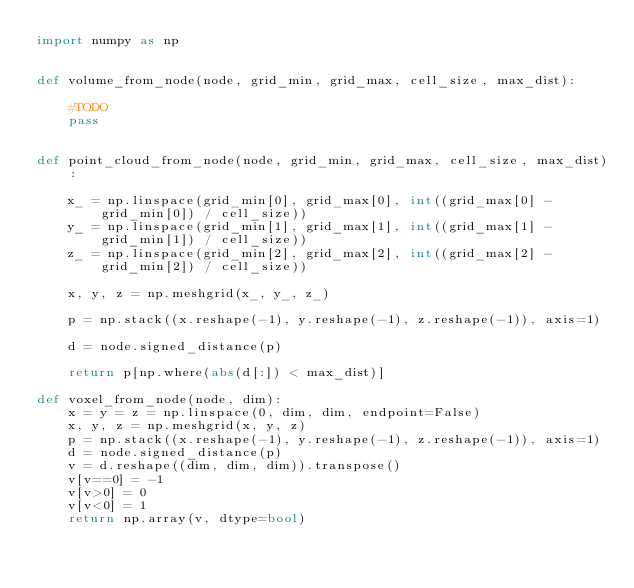<code> <loc_0><loc_0><loc_500><loc_500><_Python_>import numpy as np


def volume_from_node(node, grid_min, grid_max, cell_size, max_dist):

    #TODO
    pass


def point_cloud_from_node(node, grid_min, grid_max, cell_size, max_dist):

    x_ = np.linspace(grid_min[0], grid_max[0], int((grid_max[0] - grid_min[0]) / cell_size))
    y_ = np.linspace(grid_min[1], grid_max[1], int((grid_max[1] - grid_min[1]) / cell_size))
    z_ = np.linspace(grid_min[2], grid_max[2], int((grid_max[2] - grid_min[2]) / cell_size))

    x, y, z = np.meshgrid(x_, y_, z_)

    p = np.stack((x.reshape(-1), y.reshape(-1), z.reshape(-1)), axis=1)

    d = node.signed_distance(p)

    return p[np.where(abs(d[:]) < max_dist)]

def voxel_from_node(node, dim):
    x = y = z = np.linspace(0, dim, dim, endpoint=False)
    x, y, z = np.meshgrid(x, y, z)
    p = np.stack((x.reshape(-1), y.reshape(-1), z.reshape(-1)), axis=1)
    d = node.signed_distance(p)
    v = d.reshape((dim, dim, dim)).transpose()
    v[v==0] = -1
    v[v>0] = 0
    v[v<0] = 1
    return np.array(v, dtype=bool)
</code> 